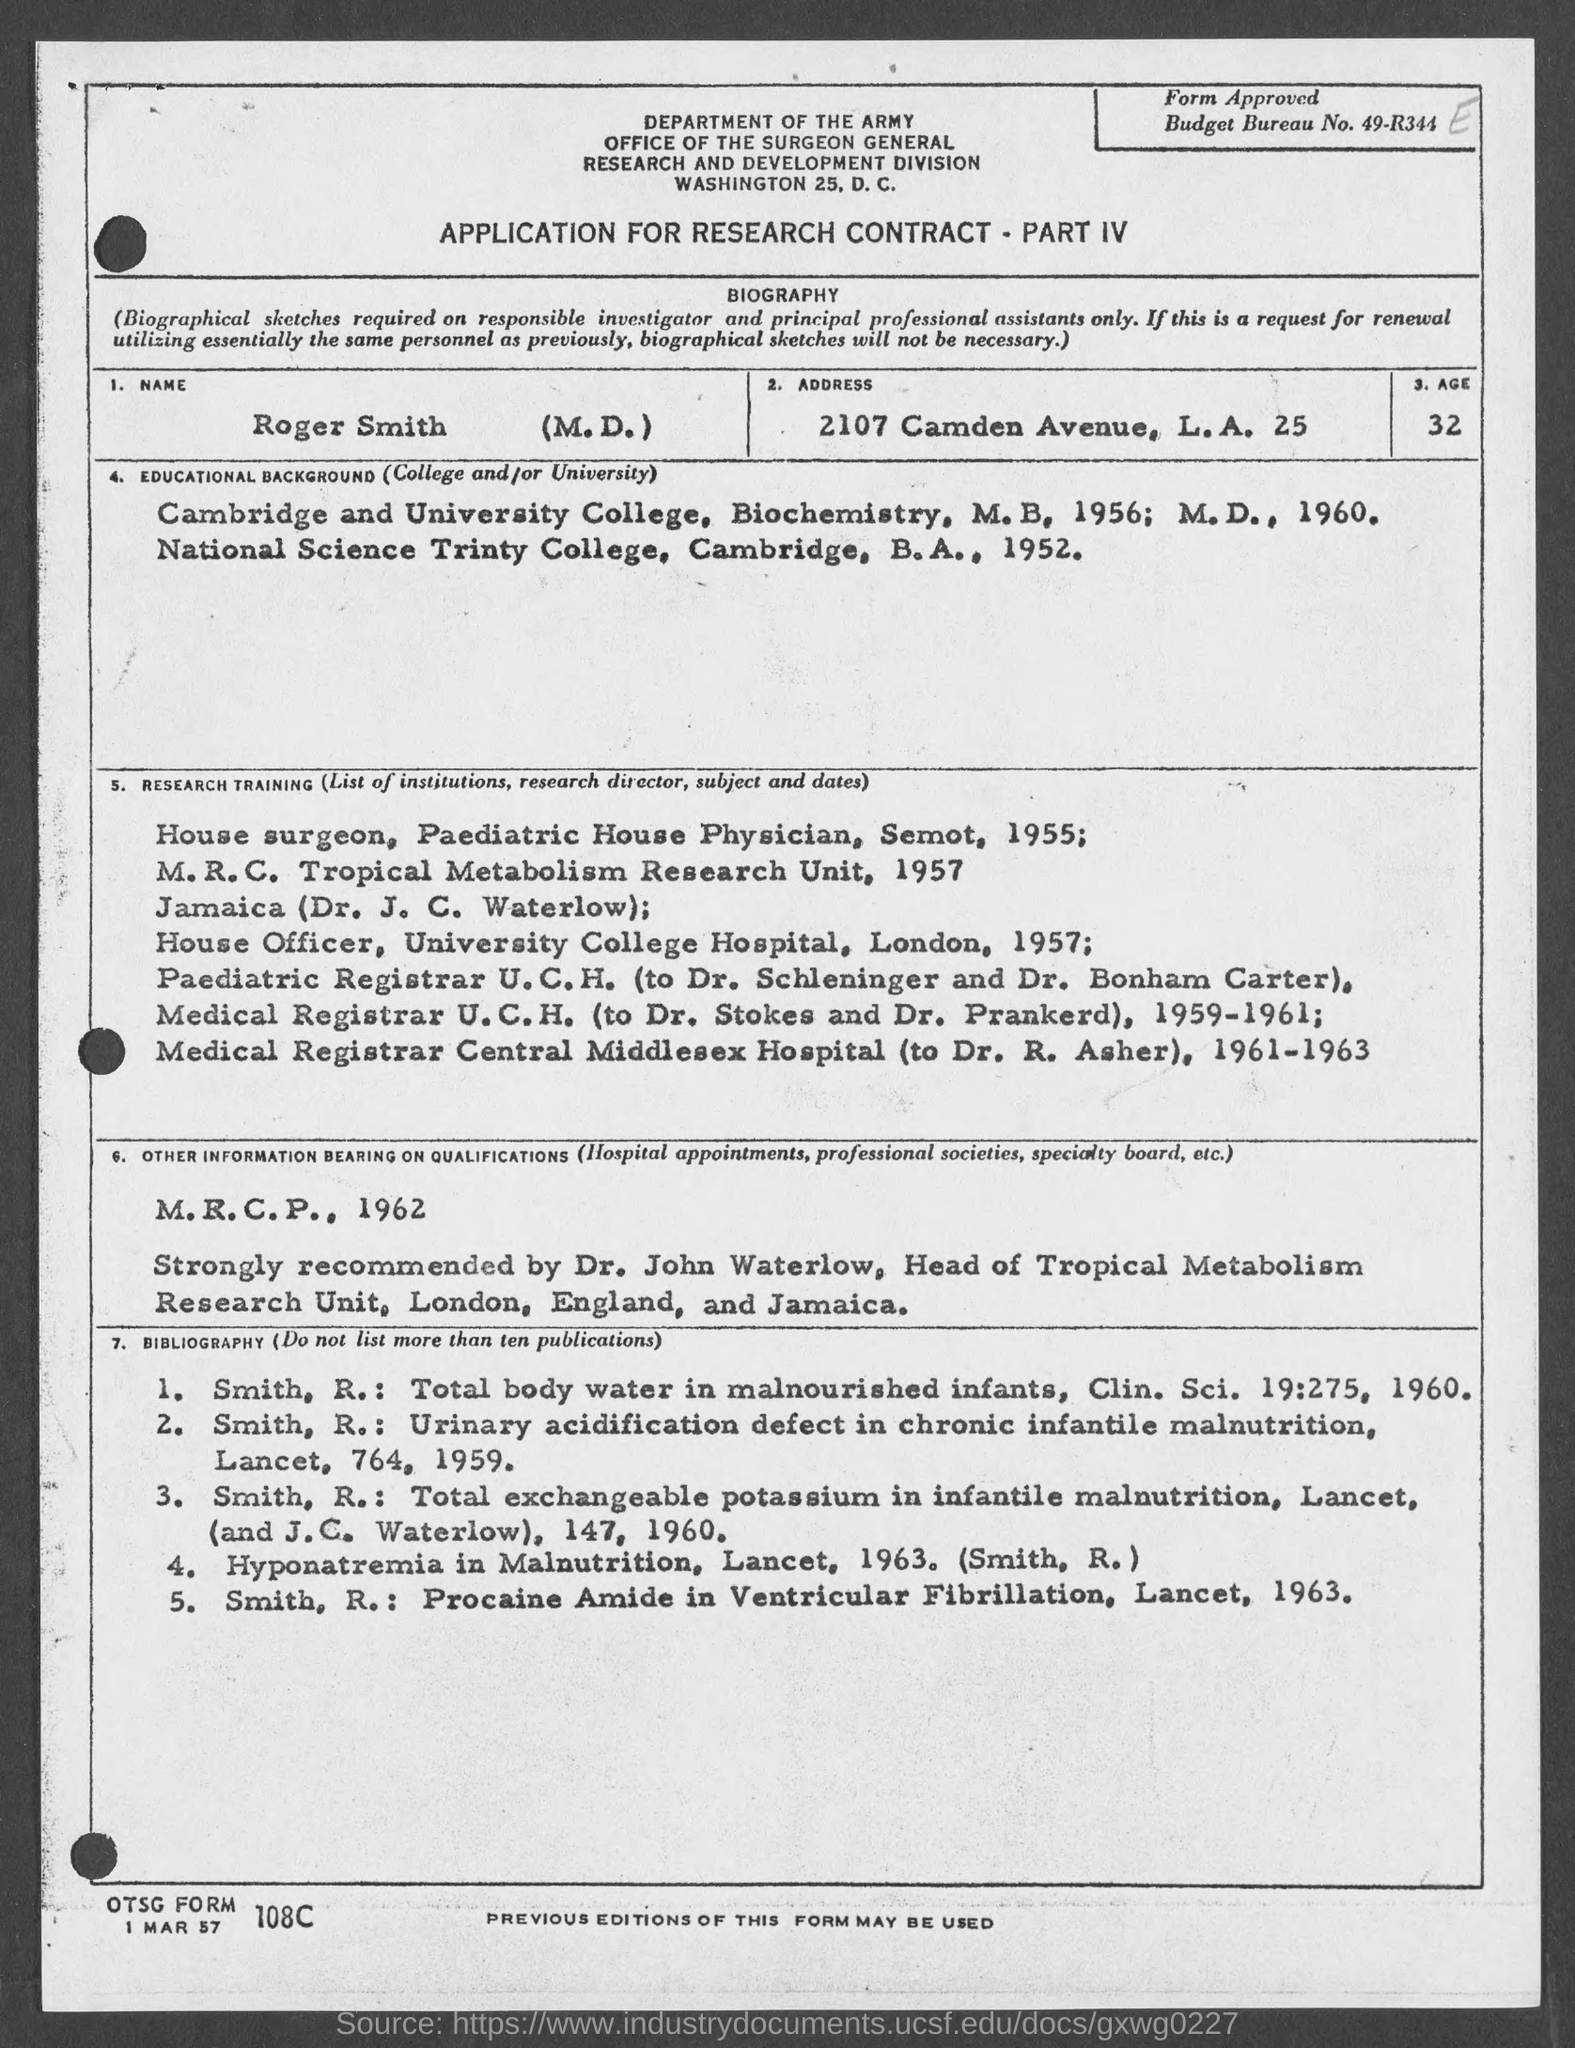What is the Budget Bureau No. given in the application form?
Ensure brevity in your answer.  49-R344. What is the Name of the person given in the Application?
Keep it short and to the point. Roger Smith (M.D.). What is the address given in the application?
Offer a terse response. 2107 Camden Avenue, L.A. 25. What is the age of Roger Smith    (M.D.) as per the application?
Provide a succinct answer. 32. During which period, Roger Smith (M.D.) worked as a Medical Registrar U.C.H. (to Dr. Stokes and Dr. Prankerd)?
Offer a terse response. 1959-1961. In which year, Roger Smith (M.D.) worked as House Officer, University College Hospital, London?
Provide a short and direct response. 1957;. 